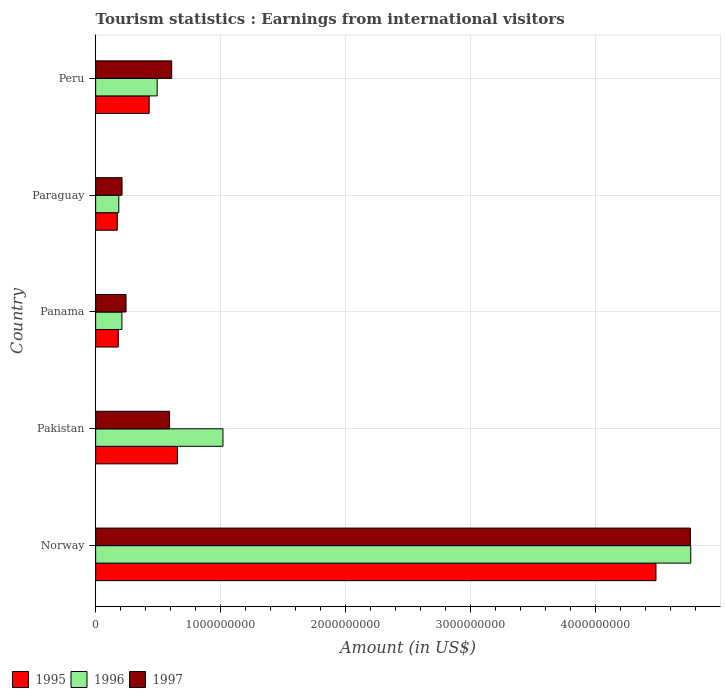How many different coloured bars are there?
Offer a very short reply. 3. Are the number of bars per tick equal to the number of legend labels?
Provide a short and direct response. Yes. How many bars are there on the 1st tick from the top?
Offer a very short reply. 3. How many bars are there on the 2nd tick from the bottom?
Your answer should be compact. 3. What is the label of the 2nd group of bars from the top?
Your response must be concise. Paraguay. In how many cases, is the number of bars for a given country not equal to the number of legend labels?
Ensure brevity in your answer.  0. What is the earnings from international visitors in 1995 in Norway?
Your answer should be compact. 4.48e+09. Across all countries, what is the maximum earnings from international visitors in 1997?
Keep it short and to the point. 4.76e+09. Across all countries, what is the minimum earnings from international visitors in 1995?
Your answer should be very brief. 1.73e+08. In which country was the earnings from international visitors in 1995 minimum?
Offer a terse response. Paraguay. What is the total earnings from international visitors in 1995 in the graph?
Your answer should be compact. 5.92e+09. What is the difference between the earnings from international visitors in 1995 in Norway and that in Panama?
Your response must be concise. 4.30e+09. What is the difference between the earnings from international visitors in 1995 in Peru and the earnings from international visitors in 1997 in Norway?
Provide a succinct answer. -4.33e+09. What is the average earnings from international visitors in 1997 per country?
Your answer should be very brief. 1.28e+09. What is the difference between the earnings from international visitors in 1997 and earnings from international visitors in 1996 in Paraguay?
Give a very brief answer. 2.60e+07. What is the ratio of the earnings from international visitors in 1997 in Panama to that in Paraguay?
Provide a short and direct response. 1.15. Is the difference between the earnings from international visitors in 1997 in Pakistan and Peru greater than the difference between the earnings from international visitors in 1996 in Pakistan and Peru?
Give a very brief answer. No. What is the difference between the highest and the second highest earnings from international visitors in 1997?
Your answer should be compact. 4.15e+09. What is the difference between the highest and the lowest earnings from international visitors in 1995?
Your answer should be very brief. 4.31e+09. Is the sum of the earnings from international visitors in 1995 in Norway and Paraguay greater than the maximum earnings from international visitors in 1997 across all countries?
Your answer should be compact. No. What does the 1st bar from the bottom in Peru represents?
Your answer should be very brief. 1995. Is it the case that in every country, the sum of the earnings from international visitors in 1995 and earnings from international visitors in 1996 is greater than the earnings from international visitors in 1997?
Offer a terse response. Yes. How many bars are there?
Give a very brief answer. 15. Are all the bars in the graph horizontal?
Your answer should be very brief. Yes. How many countries are there in the graph?
Your response must be concise. 5. Does the graph contain any zero values?
Your response must be concise. No. Does the graph contain grids?
Provide a short and direct response. Yes. Where does the legend appear in the graph?
Provide a short and direct response. Bottom left. How are the legend labels stacked?
Your answer should be compact. Horizontal. What is the title of the graph?
Give a very brief answer. Tourism statistics : Earnings from international visitors. Does "1980" appear as one of the legend labels in the graph?
Your answer should be compact. No. What is the label or title of the X-axis?
Keep it short and to the point. Amount (in US$). What is the label or title of the Y-axis?
Give a very brief answer. Country. What is the Amount (in US$) of 1995 in Norway?
Ensure brevity in your answer.  4.48e+09. What is the Amount (in US$) of 1996 in Norway?
Keep it short and to the point. 4.76e+09. What is the Amount (in US$) in 1997 in Norway?
Provide a short and direct response. 4.76e+09. What is the Amount (in US$) in 1995 in Pakistan?
Offer a terse response. 6.54e+08. What is the Amount (in US$) in 1996 in Pakistan?
Your answer should be compact. 1.02e+09. What is the Amount (in US$) of 1997 in Pakistan?
Ensure brevity in your answer.  5.91e+08. What is the Amount (in US$) in 1995 in Panama?
Give a very brief answer. 1.81e+08. What is the Amount (in US$) in 1996 in Panama?
Provide a succinct answer. 2.10e+08. What is the Amount (in US$) in 1997 in Panama?
Your response must be concise. 2.43e+08. What is the Amount (in US$) of 1995 in Paraguay?
Provide a short and direct response. 1.73e+08. What is the Amount (in US$) of 1996 in Paraguay?
Keep it short and to the point. 1.85e+08. What is the Amount (in US$) of 1997 in Paraguay?
Ensure brevity in your answer.  2.11e+08. What is the Amount (in US$) of 1995 in Peru?
Give a very brief answer. 4.28e+08. What is the Amount (in US$) in 1996 in Peru?
Make the answer very short. 4.92e+08. What is the Amount (in US$) in 1997 in Peru?
Give a very brief answer. 6.08e+08. Across all countries, what is the maximum Amount (in US$) in 1995?
Your response must be concise. 4.48e+09. Across all countries, what is the maximum Amount (in US$) in 1996?
Give a very brief answer. 4.76e+09. Across all countries, what is the maximum Amount (in US$) of 1997?
Your answer should be very brief. 4.76e+09. Across all countries, what is the minimum Amount (in US$) of 1995?
Provide a succinct answer. 1.73e+08. Across all countries, what is the minimum Amount (in US$) in 1996?
Make the answer very short. 1.85e+08. Across all countries, what is the minimum Amount (in US$) of 1997?
Your answer should be compact. 2.11e+08. What is the total Amount (in US$) in 1995 in the graph?
Make the answer very short. 5.92e+09. What is the total Amount (in US$) of 1996 in the graph?
Offer a very short reply. 6.66e+09. What is the total Amount (in US$) of 1997 in the graph?
Make the answer very short. 6.41e+09. What is the difference between the Amount (in US$) in 1995 in Norway and that in Pakistan?
Ensure brevity in your answer.  3.83e+09. What is the difference between the Amount (in US$) of 1996 in Norway and that in Pakistan?
Provide a succinct answer. 3.74e+09. What is the difference between the Amount (in US$) in 1997 in Norway and that in Pakistan?
Offer a terse response. 4.16e+09. What is the difference between the Amount (in US$) in 1995 in Norway and that in Panama?
Give a very brief answer. 4.30e+09. What is the difference between the Amount (in US$) of 1996 in Norway and that in Panama?
Ensure brevity in your answer.  4.55e+09. What is the difference between the Amount (in US$) of 1997 in Norway and that in Panama?
Make the answer very short. 4.51e+09. What is the difference between the Amount (in US$) of 1995 in Norway and that in Paraguay?
Offer a very short reply. 4.31e+09. What is the difference between the Amount (in US$) in 1996 in Norway and that in Paraguay?
Make the answer very short. 4.57e+09. What is the difference between the Amount (in US$) of 1997 in Norway and that in Paraguay?
Your answer should be compact. 4.54e+09. What is the difference between the Amount (in US$) in 1995 in Norway and that in Peru?
Ensure brevity in your answer.  4.05e+09. What is the difference between the Amount (in US$) of 1996 in Norway and that in Peru?
Your answer should be very brief. 4.27e+09. What is the difference between the Amount (in US$) in 1997 in Norway and that in Peru?
Provide a short and direct response. 4.15e+09. What is the difference between the Amount (in US$) of 1995 in Pakistan and that in Panama?
Your answer should be very brief. 4.73e+08. What is the difference between the Amount (in US$) of 1996 in Pakistan and that in Panama?
Your answer should be very brief. 8.08e+08. What is the difference between the Amount (in US$) in 1997 in Pakistan and that in Panama?
Keep it short and to the point. 3.48e+08. What is the difference between the Amount (in US$) of 1995 in Pakistan and that in Paraguay?
Offer a terse response. 4.81e+08. What is the difference between the Amount (in US$) in 1996 in Pakistan and that in Paraguay?
Your answer should be very brief. 8.33e+08. What is the difference between the Amount (in US$) in 1997 in Pakistan and that in Paraguay?
Give a very brief answer. 3.80e+08. What is the difference between the Amount (in US$) in 1995 in Pakistan and that in Peru?
Keep it short and to the point. 2.26e+08. What is the difference between the Amount (in US$) in 1996 in Pakistan and that in Peru?
Your answer should be compact. 5.26e+08. What is the difference between the Amount (in US$) of 1997 in Pakistan and that in Peru?
Keep it short and to the point. -1.70e+07. What is the difference between the Amount (in US$) of 1996 in Panama and that in Paraguay?
Keep it short and to the point. 2.50e+07. What is the difference between the Amount (in US$) of 1997 in Panama and that in Paraguay?
Your answer should be compact. 3.20e+07. What is the difference between the Amount (in US$) of 1995 in Panama and that in Peru?
Your answer should be very brief. -2.47e+08. What is the difference between the Amount (in US$) of 1996 in Panama and that in Peru?
Your answer should be very brief. -2.82e+08. What is the difference between the Amount (in US$) of 1997 in Panama and that in Peru?
Keep it short and to the point. -3.65e+08. What is the difference between the Amount (in US$) in 1995 in Paraguay and that in Peru?
Your answer should be very brief. -2.55e+08. What is the difference between the Amount (in US$) of 1996 in Paraguay and that in Peru?
Your answer should be very brief. -3.07e+08. What is the difference between the Amount (in US$) of 1997 in Paraguay and that in Peru?
Ensure brevity in your answer.  -3.97e+08. What is the difference between the Amount (in US$) in 1995 in Norway and the Amount (in US$) in 1996 in Pakistan?
Provide a succinct answer. 3.46e+09. What is the difference between the Amount (in US$) of 1995 in Norway and the Amount (in US$) of 1997 in Pakistan?
Your answer should be compact. 3.89e+09. What is the difference between the Amount (in US$) of 1996 in Norway and the Amount (in US$) of 1997 in Pakistan?
Make the answer very short. 4.17e+09. What is the difference between the Amount (in US$) in 1995 in Norway and the Amount (in US$) in 1996 in Panama?
Keep it short and to the point. 4.27e+09. What is the difference between the Amount (in US$) in 1995 in Norway and the Amount (in US$) in 1997 in Panama?
Give a very brief answer. 4.24e+09. What is the difference between the Amount (in US$) in 1996 in Norway and the Amount (in US$) in 1997 in Panama?
Give a very brief answer. 4.52e+09. What is the difference between the Amount (in US$) of 1995 in Norway and the Amount (in US$) of 1996 in Paraguay?
Keep it short and to the point. 4.30e+09. What is the difference between the Amount (in US$) of 1995 in Norway and the Amount (in US$) of 1997 in Paraguay?
Provide a short and direct response. 4.27e+09. What is the difference between the Amount (in US$) of 1996 in Norway and the Amount (in US$) of 1997 in Paraguay?
Keep it short and to the point. 4.55e+09. What is the difference between the Amount (in US$) in 1995 in Norway and the Amount (in US$) in 1996 in Peru?
Provide a short and direct response. 3.99e+09. What is the difference between the Amount (in US$) in 1995 in Norway and the Amount (in US$) in 1997 in Peru?
Your answer should be compact. 3.87e+09. What is the difference between the Amount (in US$) in 1996 in Norway and the Amount (in US$) in 1997 in Peru?
Provide a short and direct response. 4.15e+09. What is the difference between the Amount (in US$) in 1995 in Pakistan and the Amount (in US$) in 1996 in Panama?
Your response must be concise. 4.44e+08. What is the difference between the Amount (in US$) of 1995 in Pakistan and the Amount (in US$) of 1997 in Panama?
Offer a terse response. 4.11e+08. What is the difference between the Amount (in US$) of 1996 in Pakistan and the Amount (in US$) of 1997 in Panama?
Provide a short and direct response. 7.75e+08. What is the difference between the Amount (in US$) of 1995 in Pakistan and the Amount (in US$) of 1996 in Paraguay?
Give a very brief answer. 4.69e+08. What is the difference between the Amount (in US$) in 1995 in Pakistan and the Amount (in US$) in 1997 in Paraguay?
Keep it short and to the point. 4.43e+08. What is the difference between the Amount (in US$) of 1996 in Pakistan and the Amount (in US$) of 1997 in Paraguay?
Offer a very short reply. 8.07e+08. What is the difference between the Amount (in US$) of 1995 in Pakistan and the Amount (in US$) of 1996 in Peru?
Make the answer very short. 1.62e+08. What is the difference between the Amount (in US$) of 1995 in Pakistan and the Amount (in US$) of 1997 in Peru?
Keep it short and to the point. 4.60e+07. What is the difference between the Amount (in US$) in 1996 in Pakistan and the Amount (in US$) in 1997 in Peru?
Provide a succinct answer. 4.10e+08. What is the difference between the Amount (in US$) in 1995 in Panama and the Amount (in US$) in 1997 in Paraguay?
Offer a terse response. -3.00e+07. What is the difference between the Amount (in US$) in 1996 in Panama and the Amount (in US$) in 1997 in Paraguay?
Ensure brevity in your answer.  -1.00e+06. What is the difference between the Amount (in US$) in 1995 in Panama and the Amount (in US$) in 1996 in Peru?
Ensure brevity in your answer.  -3.11e+08. What is the difference between the Amount (in US$) of 1995 in Panama and the Amount (in US$) of 1997 in Peru?
Provide a succinct answer. -4.27e+08. What is the difference between the Amount (in US$) in 1996 in Panama and the Amount (in US$) in 1997 in Peru?
Offer a very short reply. -3.98e+08. What is the difference between the Amount (in US$) in 1995 in Paraguay and the Amount (in US$) in 1996 in Peru?
Your answer should be very brief. -3.19e+08. What is the difference between the Amount (in US$) of 1995 in Paraguay and the Amount (in US$) of 1997 in Peru?
Provide a succinct answer. -4.35e+08. What is the difference between the Amount (in US$) of 1996 in Paraguay and the Amount (in US$) of 1997 in Peru?
Offer a terse response. -4.23e+08. What is the average Amount (in US$) of 1995 per country?
Your answer should be compact. 1.18e+09. What is the average Amount (in US$) in 1996 per country?
Give a very brief answer. 1.33e+09. What is the average Amount (in US$) in 1997 per country?
Offer a very short reply. 1.28e+09. What is the difference between the Amount (in US$) in 1995 and Amount (in US$) in 1996 in Norway?
Your response must be concise. -2.78e+08. What is the difference between the Amount (in US$) in 1995 and Amount (in US$) in 1997 in Norway?
Your answer should be compact. -2.75e+08. What is the difference between the Amount (in US$) of 1996 and Amount (in US$) of 1997 in Norway?
Ensure brevity in your answer.  2.85e+06. What is the difference between the Amount (in US$) in 1995 and Amount (in US$) in 1996 in Pakistan?
Your answer should be compact. -3.64e+08. What is the difference between the Amount (in US$) of 1995 and Amount (in US$) of 1997 in Pakistan?
Provide a short and direct response. 6.30e+07. What is the difference between the Amount (in US$) of 1996 and Amount (in US$) of 1997 in Pakistan?
Give a very brief answer. 4.27e+08. What is the difference between the Amount (in US$) in 1995 and Amount (in US$) in 1996 in Panama?
Offer a very short reply. -2.90e+07. What is the difference between the Amount (in US$) of 1995 and Amount (in US$) of 1997 in Panama?
Your response must be concise. -6.20e+07. What is the difference between the Amount (in US$) in 1996 and Amount (in US$) in 1997 in Panama?
Offer a terse response. -3.30e+07. What is the difference between the Amount (in US$) of 1995 and Amount (in US$) of 1996 in Paraguay?
Provide a succinct answer. -1.20e+07. What is the difference between the Amount (in US$) of 1995 and Amount (in US$) of 1997 in Paraguay?
Provide a short and direct response. -3.80e+07. What is the difference between the Amount (in US$) in 1996 and Amount (in US$) in 1997 in Paraguay?
Provide a short and direct response. -2.60e+07. What is the difference between the Amount (in US$) in 1995 and Amount (in US$) in 1996 in Peru?
Keep it short and to the point. -6.40e+07. What is the difference between the Amount (in US$) in 1995 and Amount (in US$) in 1997 in Peru?
Ensure brevity in your answer.  -1.80e+08. What is the difference between the Amount (in US$) of 1996 and Amount (in US$) of 1997 in Peru?
Offer a very short reply. -1.16e+08. What is the ratio of the Amount (in US$) of 1995 in Norway to that in Pakistan?
Offer a very short reply. 6.85. What is the ratio of the Amount (in US$) in 1996 in Norway to that in Pakistan?
Your answer should be very brief. 4.67. What is the ratio of the Amount (in US$) in 1997 in Norway to that in Pakistan?
Provide a succinct answer. 8.05. What is the ratio of the Amount (in US$) of 1995 in Norway to that in Panama?
Give a very brief answer. 24.76. What is the ratio of the Amount (in US$) of 1996 in Norway to that in Panama?
Your answer should be compact. 22.66. What is the ratio of the Amount (in US$) of 1997 in Norway to that in Panama?
Your response must be concise. 19.57. What is the ratio of the Amount (in US$) in 1995 in Norway to that in Paraguay?
Offer a very short reply. 25.9. What is the ratio of the Amount (in US$) in 1996 in Norway to that in Paraguay?
Offer a terse response. 25.72. What is the ratio of the Amount (in US$) of 1997 in Norway to that in Paraguay?
Give a very brief answer. 22.54. What is the ratio of the Amount (in US$) in 1995 in Norway to that in Peru?
Your answer should be very brief. 10.47. What is the ratio of the Amount (in US$) in 1996 in Norway to that in Peru?
Offer a very short reply. 9.67. What is the ratio of the Amount (in US$) of 1997 in Norway to that in Peru?
Provide a succinct answer. 7.82. What is the ratio of the Amount (in US$) of 1995 in Pakistan to that in Panama?
Offer a very short reply. 3.61. What is the ratio of the Amount (in US$) in 1996 in Pakistan to that in Panama?
Make the answer very short. 4.85. What is the ratio of the Amount (in US$) in 1997 in Pakistan to that in Panama?
Your answer should be very brief. 2.43. What is the ratio of the Amount (in US$) of 1995 in Pakistan to that in Paraguay?
Provide a succinct answer. 3.78. What is the ratio of the Amount (in US$) in 1996 in Pakistan to that in Paraguay?
Your answer should be compact. 5.5. What is the ratio of the Amount (in US$) of 1997 in Pakistan to that in Paraguay?
Give a very brief answer. 2.8. What is the ratio of the Amount (in US$) of 1995 in Pakistan to that in Peru?
Provide a succinct answer. 1.53. What is the ratio of the Amount (in US$) in 1996 in Pakistan to that in Peru?
Provide a succinct answer. 2.07. What is the ratio of the Amount (in US$) in 1997 in Pakistan to that in Peru?
Your answer should be very brief. 0.97. What is the ratio of the Amount (in US$) in 1995 in Panama to that in Paraguay?
Your response must be concise. 1.05. What is the ratio of the Amount (in US$) in 1996 in Panama to that in Paraguay?
Keep it short and to the point. 1.14. What is the ratio of the Amount (in US$) in 1997 in Panama to that in Paraguay?
Ensure brevity in your answer.  1.15. What is the ratio of the Amount (in US$) of 1995 in Panama to that in Peru?
Offer a very short reply. 0.42. What is the ratio of the Amount (in US$) of 1996 in Panama to that in Peru?
Offer a terse response. 0.43. What is the ratio of the Amount (in US$) of 1997 in Panama to that in Peru?
Ensure brevity in your answer.  0.4. What is the ratio of the Amount (in US$) of 1995 in Paraguay to that in Peru?
Offer a very short reply. 0.4. What is the ratio of the Amount (in US$) in 1996 in Paraguay to that in Peru?
Give a very brief answer. 0.38. What is the ratio of the Amount (in US$) of 1997 in Paraguay to that in Peru?
Your answer should be compact. 0.35. What is the difference between the highest and the second highest Amount (in US$) in 1995?
Provide a succinct answer. 3.83e+09. What is the difference between the highest and the second highest Amount (in US$) in 1996?
Give a very brief answer. 3.74e+09. What is the difference between the highest and the second highest Amount (in US$) in 1997?
Ensure brevity in your answer.  4.15e+09. What is the difference between the highest and the lowest Amount (in US$) of 1995?
Provide a short and direct response. 4.31e+09. What is the difference between the highest and the lowest Amount (in US$) in 1996?
Ensure brevity in your answer.  4.57e+09. What is the difference between the highest and the lowest Amount (in US$) of 1997?
Your answer should be compact. 4.54e+09. 